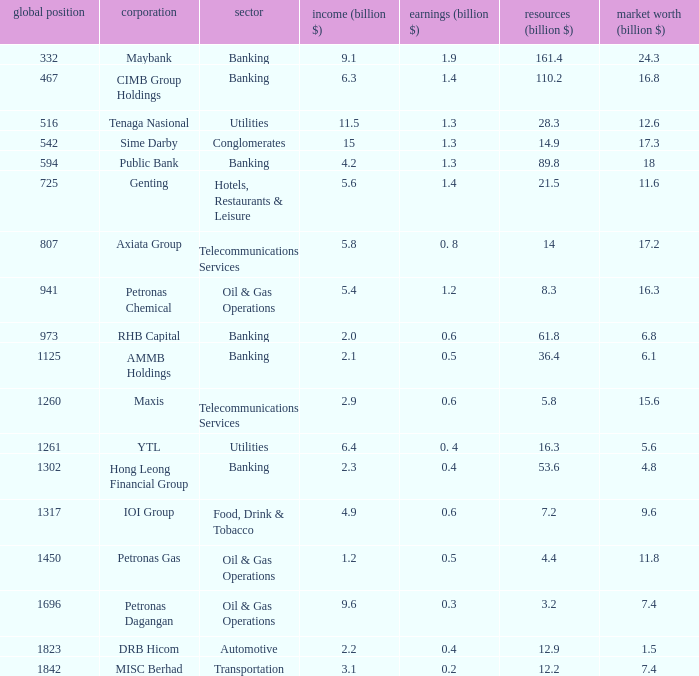Name the profits for market value of 11.8 0.5. 